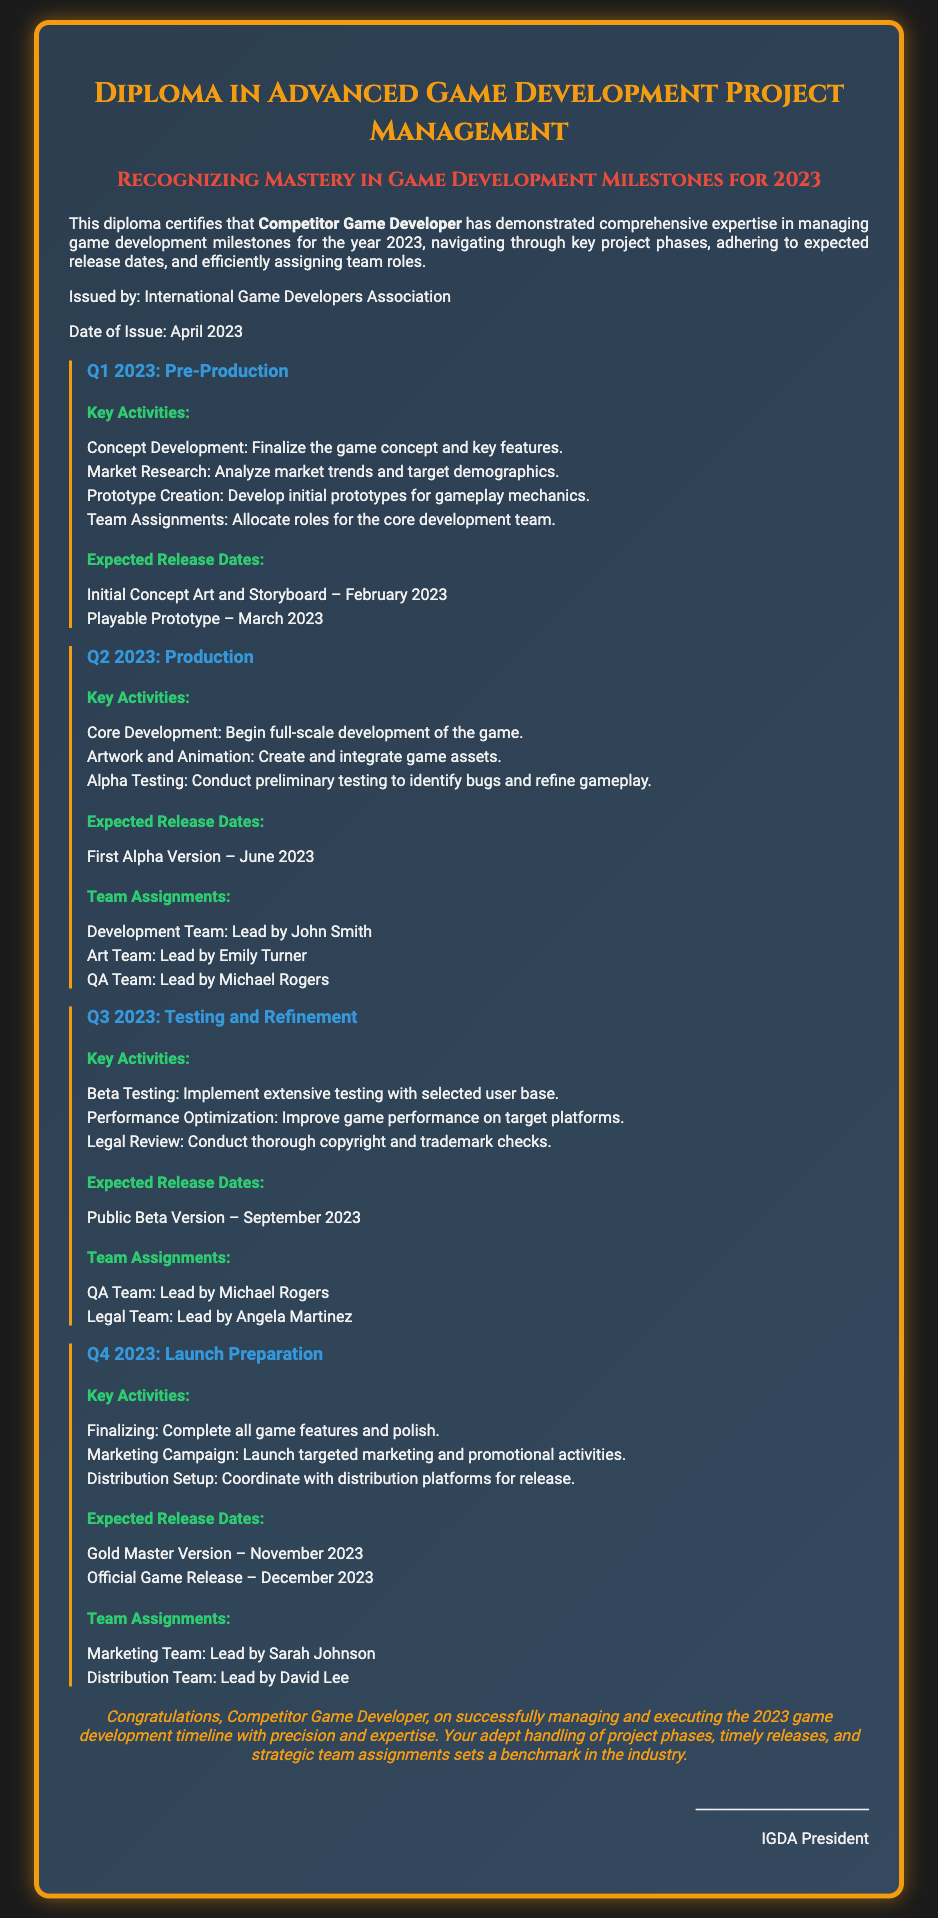What is the title of the diploma? The title of the diploma is presented at the top of the document.
Answer: Diploma in Advanced Game Development Project Management Who is the diploma issued by? The issuer of the diploma is stated in the content section.
Answer: International Game Developers Association What is the expected release date for the playable prototype? The release date for the playable prototype is listed under Q1 2023 milestones.
Answer: March 2023 Who leads the Development Team in Q2 2023? The document specifies team lead assignments for Q2 2023.
Answer: John Smith What is the release date for the Gold Master Version? This release date is mentioned in the Q4 2023 section.
Answer: November 2023 What key activity is planned for Q3 2023? Key activities are outlined under each quarter, which includes testing phases.
Answer: Beta Testing Which team is responsible for legal review in Q3 2023? The team assignments for each quarter specify roles and responsibilities.
Answer: Legal Team What is the expected release date for the Official Game Release? This date is included in the expected release dates for Q4 2023.
Answer: December 2023 What type of testing is conducted in Q3 2023? The document lists specific types of testing for each quarter.
Answer: Beta Testing 